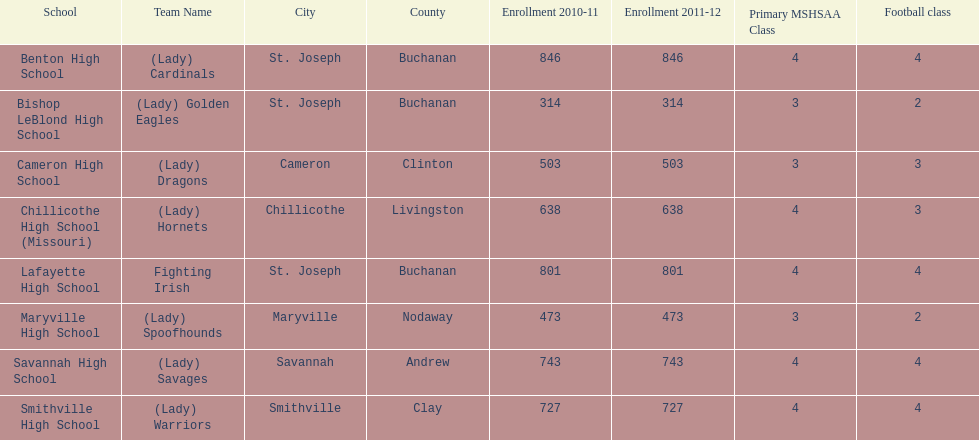Does lafayette high school or benton high school have green and grey as their colors? Lafayette High School. 